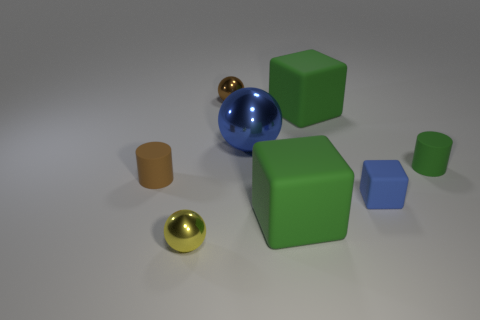Subtract all tiny metallic spheres. How many spheres are left? 1 Add 2 small blue matte cubes. How many objects exist? 10 Subtract all blue cubes. How many cubes are left? 2 Subtract 2 balls. How many balls are left? 1 Add 4 blue shiny things. How many blue shiny things are left? 5 Add 6 blue metal spheres. How many blue metal spheres exist? 7 Subtract 0 gray blocks. How many objects are left? 8 Subtract all cylinders. How many objects are left? 6 Subtract all green spheres. Subtract all green blocks. How many spheres are left? 3 Subtract all blue cylinders. How many gray balls are left? 0 